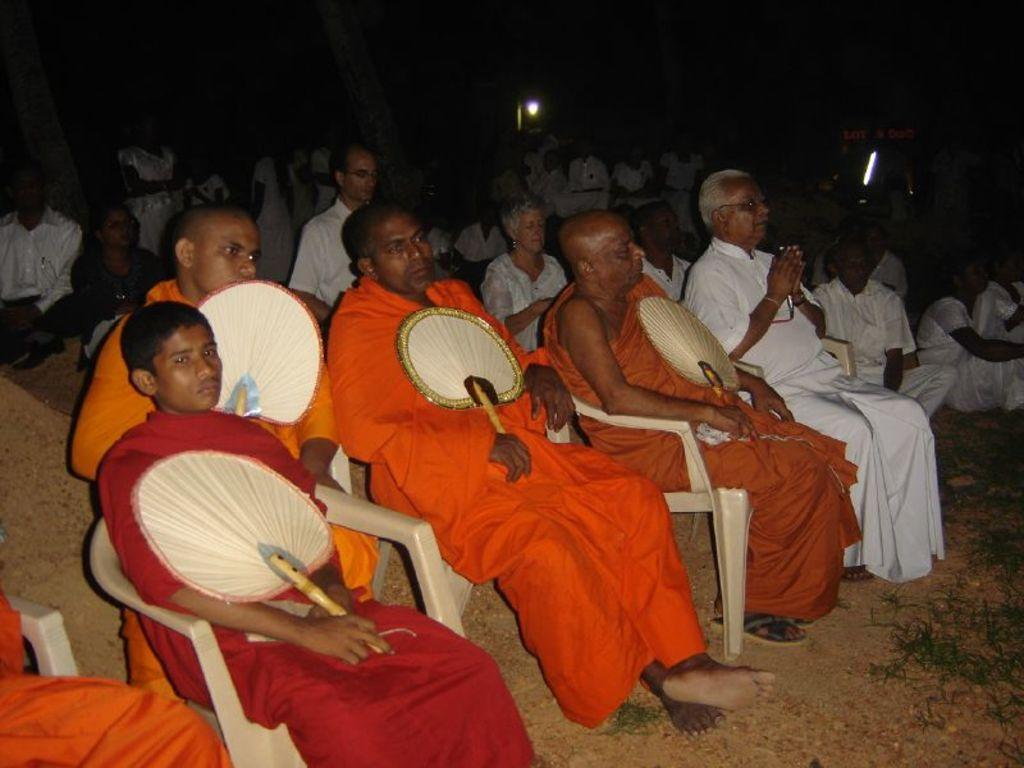What are the people in the image doing? There is a group of people sitting on chairs in the image. What objects are the people holding? The people are holding fans. Can you describe the background of the image? There are other people and lights visible in the background of the image. What type of sock is the person in the image wearing on their stomach? There is no sock or person wearing a sock on their stomach in the image. 